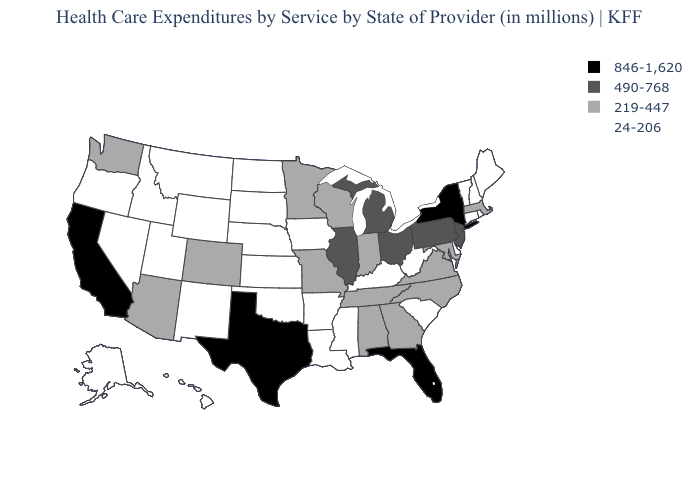Among the states that border Maryland , does Pennsylvania have the highest value?
Concise answer only. Yes. Name the states that have a value in the range 490-768?
Quick response, please. Illinois, Michigan, New Jersey, Ohio, Pennsylvania. Which states have the highest value in the USA?
Be succinct. California, Florida, New York, Texas. Does the map have missing data?
Answer briefly. No. What is the value of Iowa?
Short answer required. 24-206. Among the states that border New York , which have the highest value?
Concise answer only. New Jersey, Pennsylvania. What is the value of Tennessee?
Quick response, please. 219-447. What is the value of North Carolina?
Short answer required. 219-447. What is the lowest value in the USA?
Concise answer only. 24-206. Among the states that border Vermont , which have the highest value?
Keep it brief. New York. Does Ohio have a higher value than Illinois?
Short answer required. No. Name the states that have a value in the range 490-768?
Concise answer only. Illinois, Michigan, New Jersey, Ohio, Pennsylvania. What is the value of Rhode Island?
Concise answer only. 24-206. 